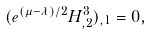<formula> <loc_0><loc_0><loc_500><loc_500>( e ^ { ( \mu - \lambda ) / 2 } H ^ { 3 } _ { , 2 } ) _ { , 1 } = 0 ,</formula> 